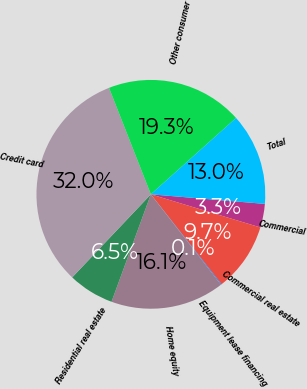<chart> <loc_0><loc_0><loc_500><loc_500><pie_chart><fcel>Commercial<fcel>Commercial real estate<fcel>Equipment lease financing<fcel>Home equity<fcel>Residential real estate<fcel>Credit card<fcel>Other consumer<fcel>Total<nl><fcel>3.34%<fcel>9.72%<fcel>0.1%<fcel>16.09%<fcel>6.48%<fcel>31.97%<fcel>19.33%<fcel>12.96%<nl></chart> 